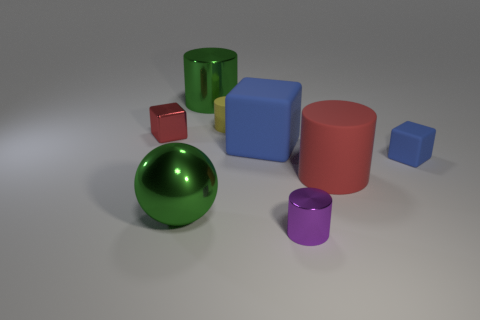The rubber object that is the same color as the metal block is what shape?
Your response must be concise. Cylinder. What is the color of the cylinder that is in front of the tiny yellow thing and behind the purple cylinder?
Provide a short and direct response. Red. Is the size of the cylinder left of the small yellow rubber thing the same as the rubber cylinder to the right of the small yellow thing?
Provide a succinct answer. Yes. How many other objects are the same size as the red metal cube?
Offer a terse response. 3. What number of large green cylinders are behind the small metallic object in front of the big red thing?
Ensure brevity in your answer.  1. Is the number of big red things that are to the left of the yellow matte cylinder less than the number of matte cubes?
Your answer should be very brief. Yes. What shape is the small object left of the green cylinder behind the metallic object to the left of the large metal sphere?
Ensure brevity in your answer.  Cube. Is the tiny purple thing the same shape as the large red thing?
Your response must be concise. Yes. How many other objects are the same shape as the tiny red object?
Make the answer very short. 2. There is another matte block that is the same size as the red block; what color is it?
Make the answer very short. Blue. 